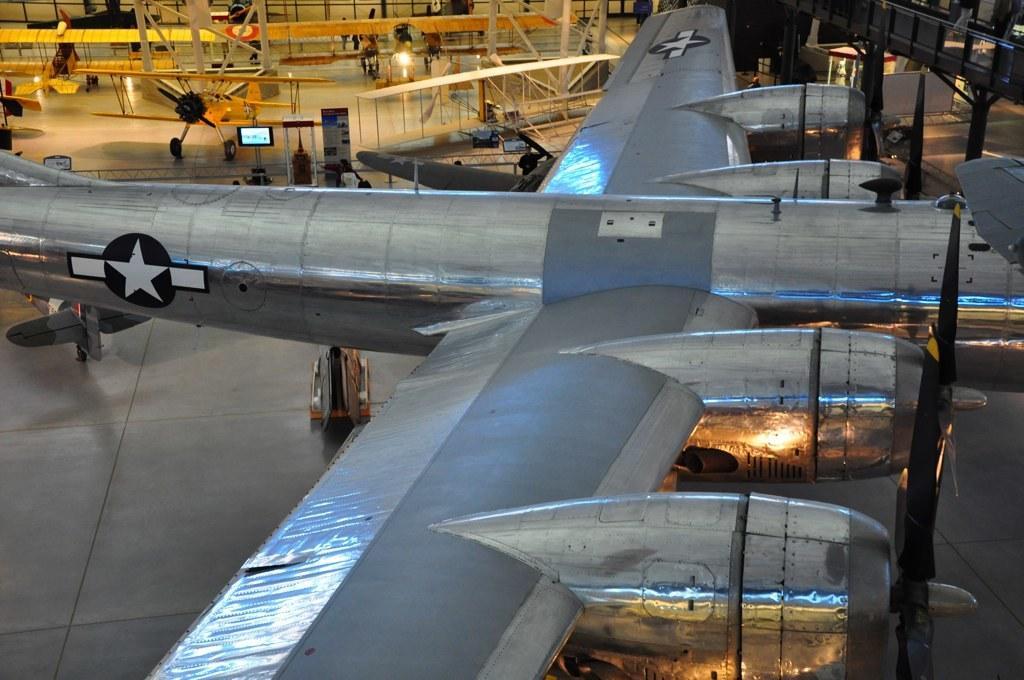In one or two sentences, can you explain what this image depicts? In this picture I can see a plan on the surface, behind we can see few planes and also I can see few people. 